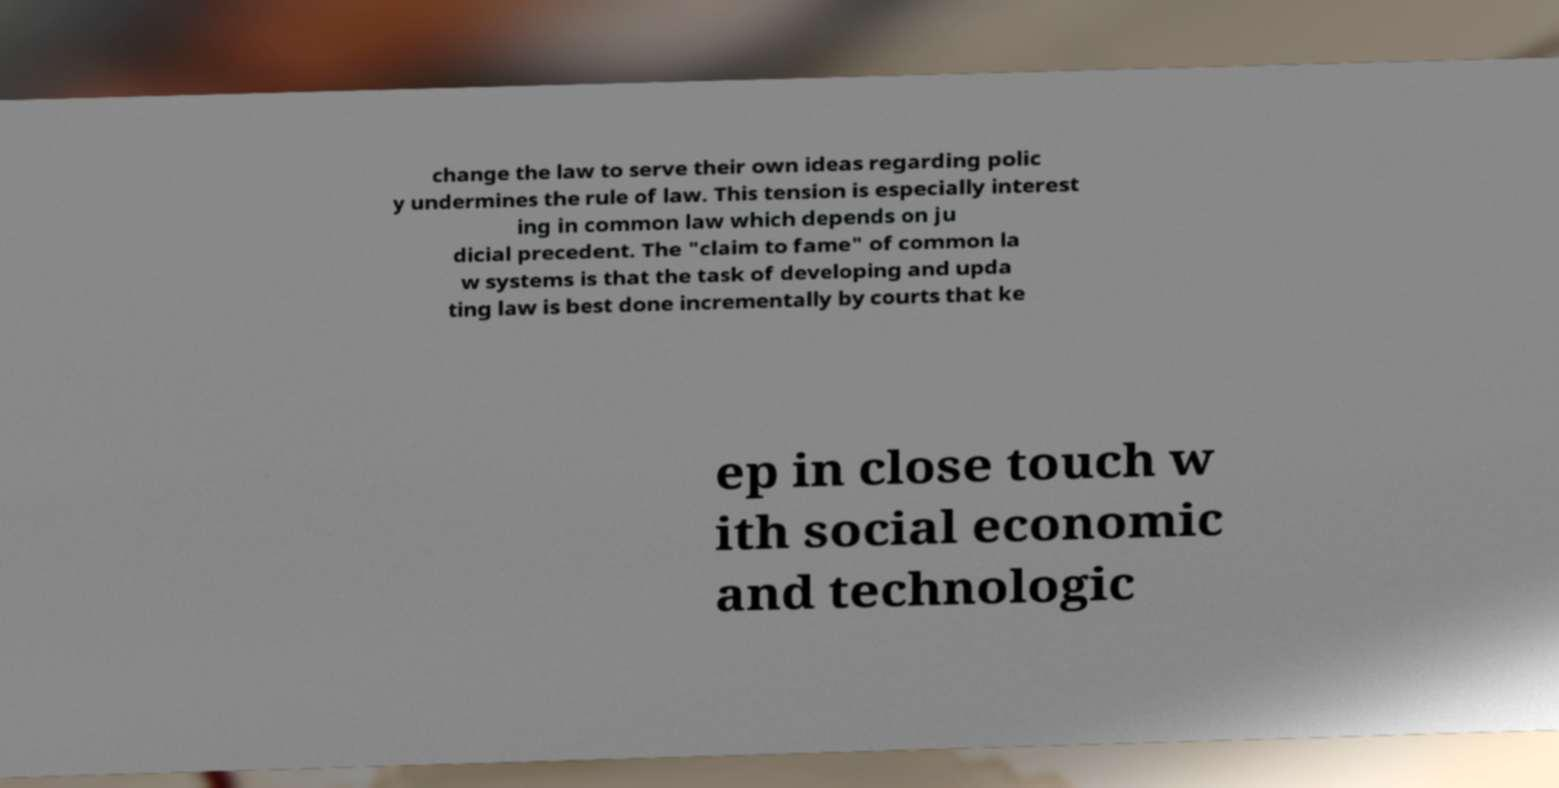I need the written content from this picture converted into text. Can you do that? change the law to serve their own ideas regarding polic y undermines the rule of law. This tension is especially interest ing in common law which depends on ju dicial precedent. The "claim to fame" of common la w systems is that the task of developing and upda ting law is best done incrementally by courts that ke ep in close touch w ith social economic and technologic 